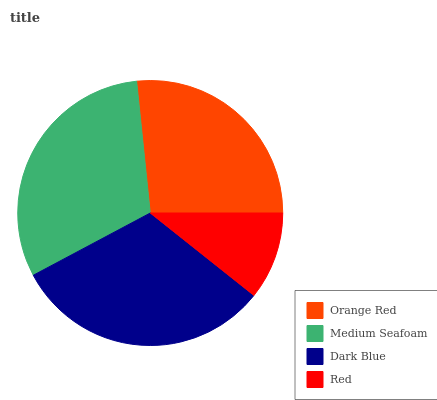Is Red the minimum?
Answer yes or no. Yes. Is Dark Blue the maximum?
Answer yes or no. Yes. Is Medium Seafoam the minimum?
Answer yes or no. No. Is Medium Seafoam the maximum?
Answer yes or no. No. Is Medium Seafoam greater than Orange Red?
Answer yes or no. Yes. Is Orange Red less than Medium Seafoam?
Answer yes or no. Yes. Is Orange Red greater than Medium Seafoam?
Answer yes or no. No. Is Medium Seafoam less than Orange Red?
Answer yes or no. No. Is Medium Seafoam the high median?
Answer yes or no. Yes. Is Orange Red the low median?
Answer yes or no. Yes. Is Orange Red the high median?
Answer yes or no. No. Is Red the low median?
Answer yes or no. No. 